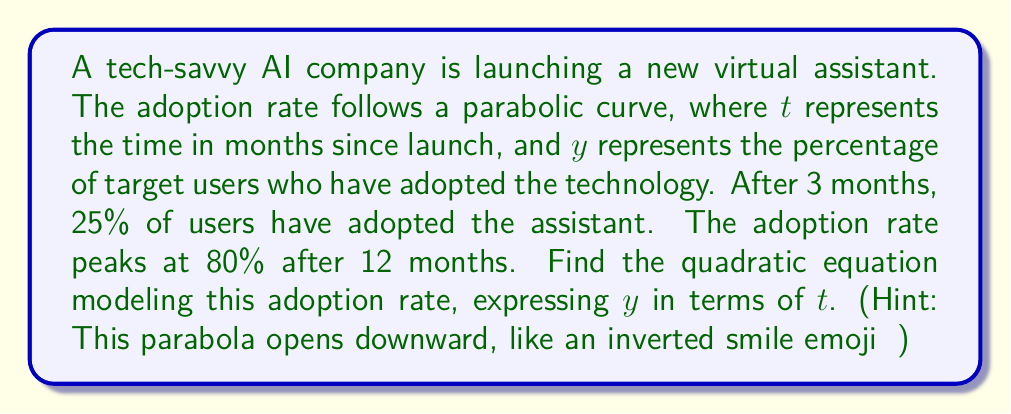Can you solve this math problem? Let's approach this step-by-step:

1) The general form of a quadratic equation is $y = a(t-h)^2 + k$, where $(h,k)$ is the vertex.

2) We know the vertex is at (12, 80), as this is where the adoption rate peaks. So, $h=12$ and $k=80$.

3) Our equation now looks like: $y = a(t-12)^2 + 80$

4) We can use the other given point (3, 25) to find $a$:

   $25 = a(3-12)^2 + 80$
   $25 = a(-9)^2 + 80$
   $25 = 81a + 80$
   $-55 = 81a$
   $a = -\frac{55}{81}$

5) Therefore, our final equation is:

   $y = -\frac{55}{81}(t-12)^2 + 80$

6) We can expand this to standard form $y = at^2 + bt + c$:

   $y = -\frac{55}{81}(t^2 - 24t + 144) + 80$
   $y = -\frac{55}{81}t^2 + \frac{1320}{81}t - \frac{7920}{81} + \frac{6480}{81}$
   $y = -\frac{55}{81}t^2 + \frac{1320}{81}t - \frac{1440}{81}$

This equation models the adoption rate of the new AI virtual assistant over time.
Answer: $y = -\frac{55}{81}t^2 + \frac{1320}{81}t - \frac{1440}{81}$ 